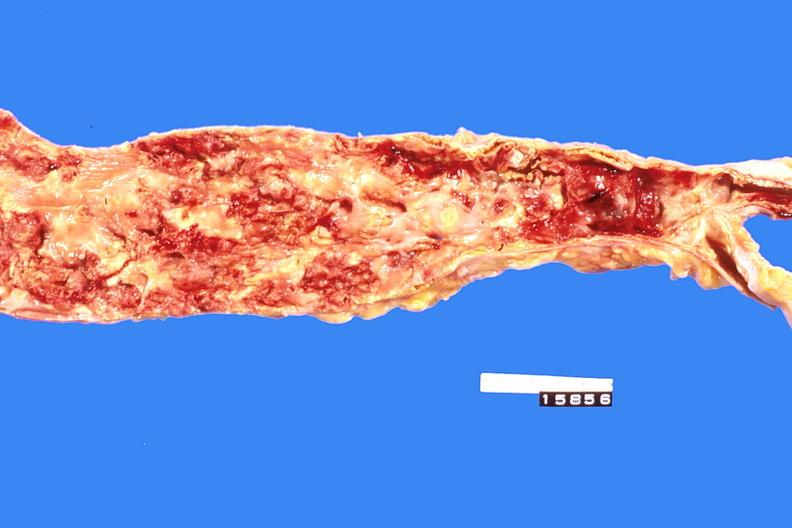does this image show abdominal aorta, severe atherosclerosis?
Answer the question using a single word or phrase. Yes 